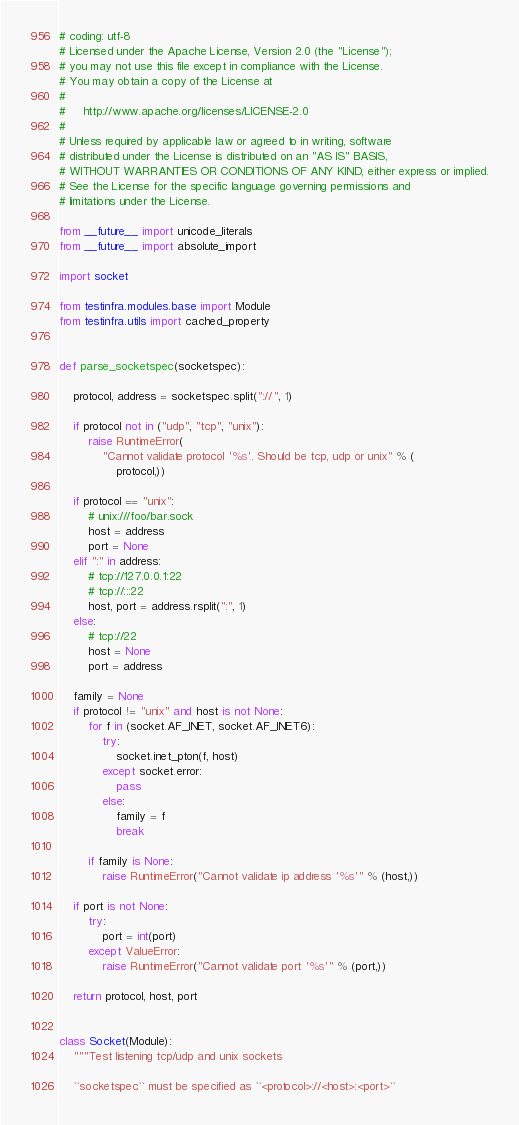Convert code to text. <code><loc_0><loc_0><loc_500><loc_500><_Python_># coding: utf-8
# Licensed under the Apache License, Version 2.0 (the "License");
# you may not use this file except in compliance with the License.
# You may obtain a copy of the License at
#
#     http://www.apache.org/licenses/LICENSE-2.0
#
# Unless required by applicable law or agreed to in writing, software
# distributed under the License is distributed on an "AS IS" BASIS,
# WITHOUT WARRANTIES OR CONDITIONS OF ANY KIND, either express or implied.
# See the License for the specific language governing permissions and
# limitations under the License.

from __future__ import unicode_literals
from __future__ import absolute_import

import socket

from testinfra.modules.base import Module
from testinfra.utils import cached_property


def parse_socketspec(socketspec):

    protocol, address = socketspec.split("://", 1)

    if protocol not in ("udp", "tcp", "unix"):
        raise RuntimeError(
            "Cannot validate protocol '%s'. Should be tcp, udp or unix" % (
                protocol,))

    if protocol == "unix":
        # unix:///foo/bar.sock
        host = address
        port = None
    elif ":" in address:
        # tcp://127.0.0.1:22
        # tcp://:::22
        host, port = address.rsplit(":", 1)
    else:
        # tcp://22
        host = None
        port = address

    family = None
    if protocol != "unix" and host is not None:
        for f in (socket.AF_INET, socket.AF_INET6):
            try:
                socket.inet_pton(f, host)
            except socket.error:
                pass
            else:
                family = f
                break

        if family is None:
            raise RuntimeError("Cannot validate ip address '%s'" % (host,))

    if port is not None:
        try:
            port = int(port)
        except ValueError:
            raise RuntimeError("Cannot validate port '%s'" % (port,))

    return protocol, host, port


class Socket(Module):
    """Test listening tcp/udp and unix sockets

    ``socketspec`` must be specified as ``<protocol>://<host>:<port>``
</code> 